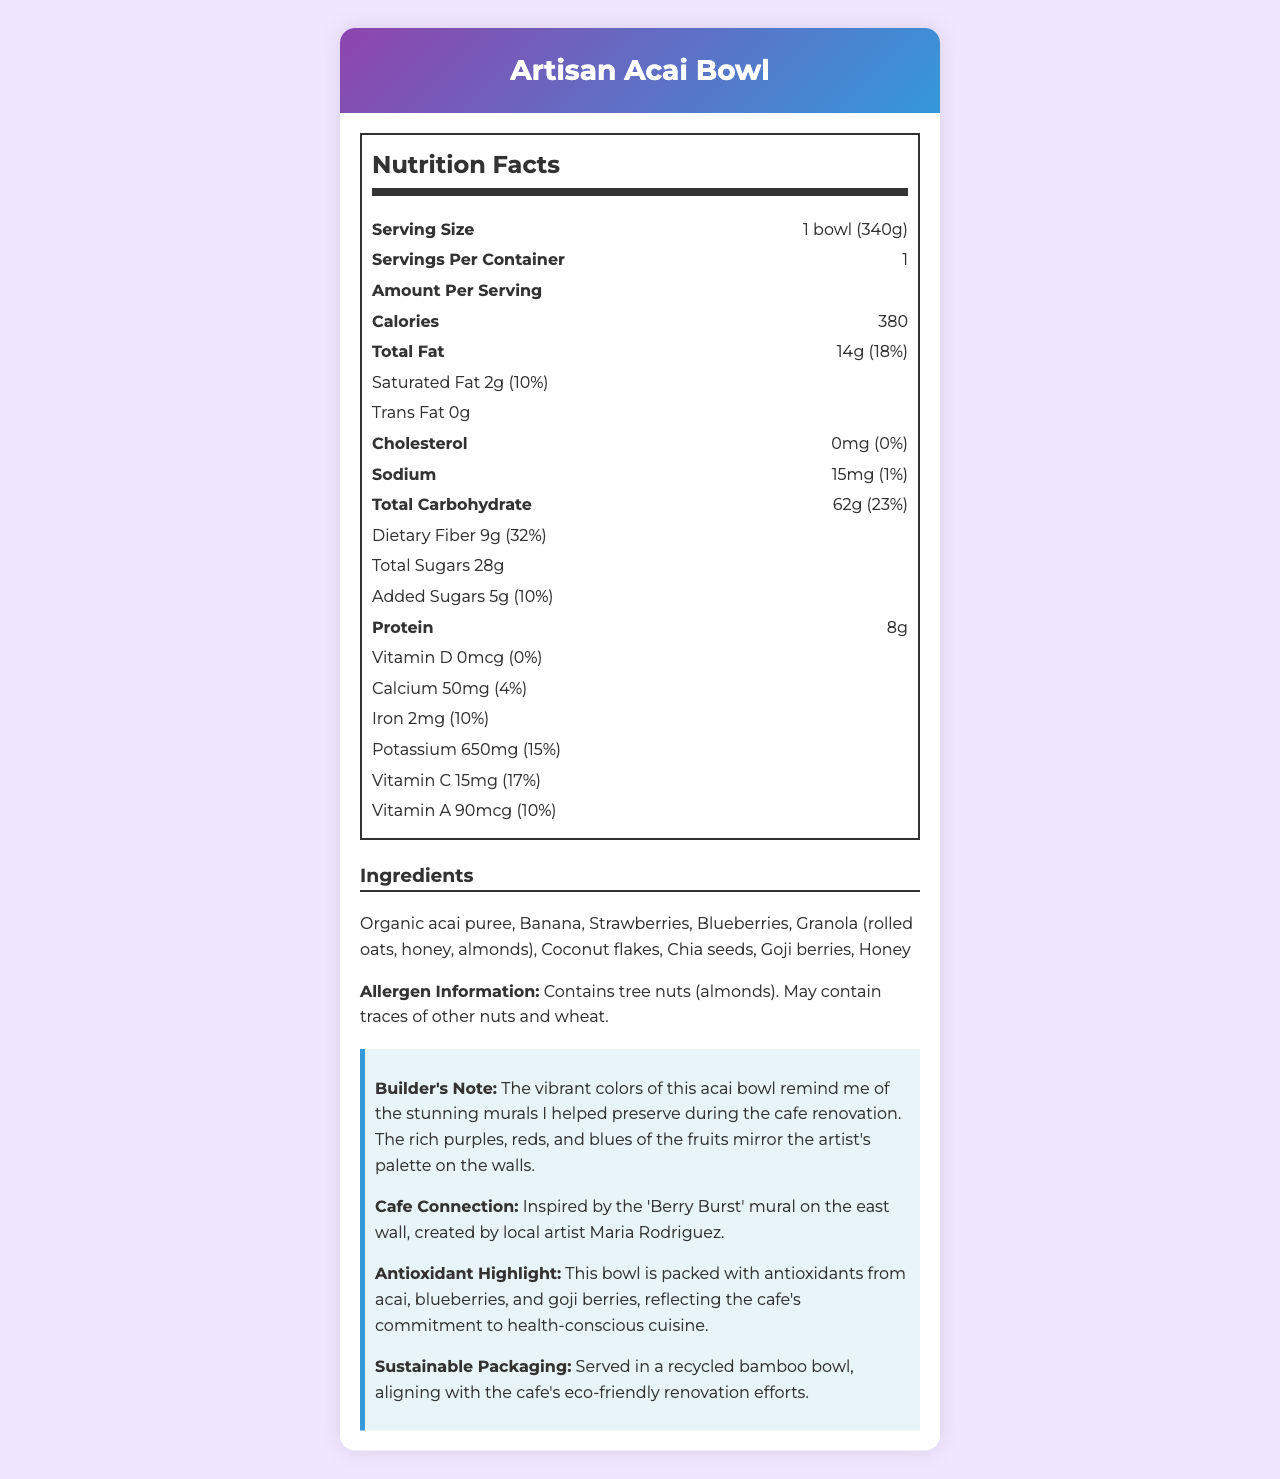what is the serving size? The serving size is clearly stated as "1 bowl (340g)" in the document.
Answer: 1 bowl (340g) how many calories are in one serving? The document specifies that one serving contains 380 calories.
Answer: 380 how much dietary fiber is in one serving? The amount of dietary fiber per serving is listed as 9g in the document.
Answer: 9g what percentage of the daily value for iron does one serving provide? One serving provides 10% of the daily value for iron, as indicated in the document.
Answer: 10% what ingredient provides the main antioxidant highlight in the acai bowl? The document highlights that acai, blueberries, and goji berries are the main sources of antioxidants.
Answer: Acai, blueberries, and goji berries does the product contain any tree nuts? The allergen information states that the product contains tree nuts (almonds).
Answer: Yes what is the total carbohydrate content per serving? The total carbohydrate content per serving is listed as 62g.
Answer: 62g how much vitamin C is in one serving? A. 10mg B. 15mg C. 20mg D. 25mg One serving contains 15mg of vitamin C.
Answer: B what is the daily value percentage for calcium provided by one serving? A. 2% B. 4% C. 6% D. 8% The document indicates that one serving provides 4% of the daily value for calcium.
Answer: B is the product free from trans fat? The document states that the product contains 0g of trans fat.
Answer: Yes summarize the main highlights of the document. The document includes detailed nutritional information, emphasizing beneficial nutrients and ingredients while connecting the product to the cafe's artistic and eco-friendly values.
Answer: The document provides the nutrition facts for an "Artisan Acai Bowl," showing a serving size of 1 bowl (340g) with 380 calories. It highlights significant amounts of dietary fiber, antioxidants, and vitamins from ingredients like acai, blueberries, and goji berries. The allergen information mentions that the bowl contains tree nuts (almonds) and may have traces of other nuts and wheat. The product reflects the cafe's colorful artwork and commitment to health and sustainability. how many milligrams of sodium are in one serving? The sodium content per serving is 15mg, as specified in the document.
Answer: 15mg what is the total sugar content per serving? The total sugar content per serving is listed as 28g.
Answer: 28g what type of mural inspired the Artisan Acai Bowl? The document states that the Artisan Acai Bowl was inspired by the "Berry Burst" mural.
Answer: Berry Burst mural what is the main ingredient of the granola used in the acai bowl? The granola is made with rolled oats, honey, and almonds as stated in the ingredients list.
Answer: Rolled oats which vitamin is not present in the acai bowl? The document confirms that the bowl contains 0mcg of Vitamin D, providing 0% of the daily value.
Answer: Vitamin D what are the daily value percentages for both saturated fat and added sugars? The document shows that both saturated fat and added sugars each have a daily value percentage of 10%.
Answer: 10% for both how does the recycled bamboo bowl relate to the cafe's efforts? The document notes that serving the acai bowl in a recycled bamboo bowl aligns with the cafe’s commitment to sustainability.
Answer: Aligns with the cafe's eco-friendly renovation efforts does the document provide the exact amount of antioxidants in the acai bowl? While the document mentions that the acai bowl is packed with antioxidants, it does not provide a specific measurement for the amount of antioxidants.
Answer: Not enough information what is the source of the artistic inspiration for the Artisan Acai Bowl? The document states that the "Berry Burst" mural on the east wall was created by local artist Maria Rodriguez, serving as the inspiration for the acai bowl.
Answer: Local artist Maria Rodriguez 